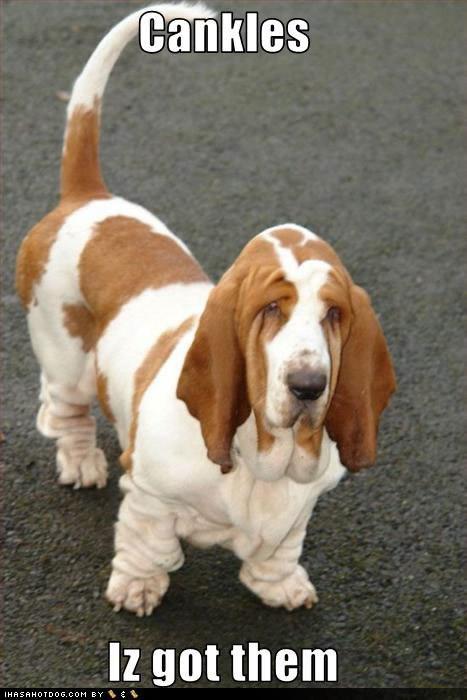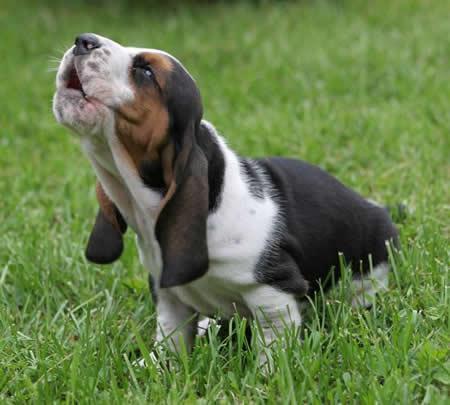The first image is the image on the left, the second image is the image on the right. Assess this claim about the two images: "At least one of the dogs is sitting on the grass.". Correct or not? Answer yes or no. Yes. The first image is the image on the left, the second image is the image on the right. Assess this claim about the two images: "Each image contains exactly one basset hound, with one sitting and one standing.". Correct or not? Answer yes or no. Yes. 